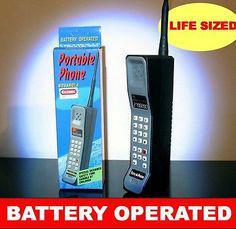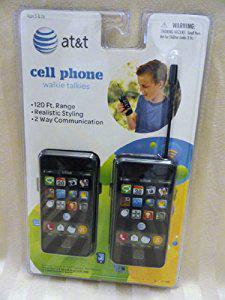The first image is the image on the left, the second image is the image on the right. Analyze the images presented: Is the assertion "At least one phone is upright next to a box." valid? Answer yes or no. Yes. The first image is the image on the left, the second image is the image on the right. For the images displayed, is the sentence "Each image includes a horizontal row of various cell phones displayed upright in size order." factually correct? Answer yes or no. No. 